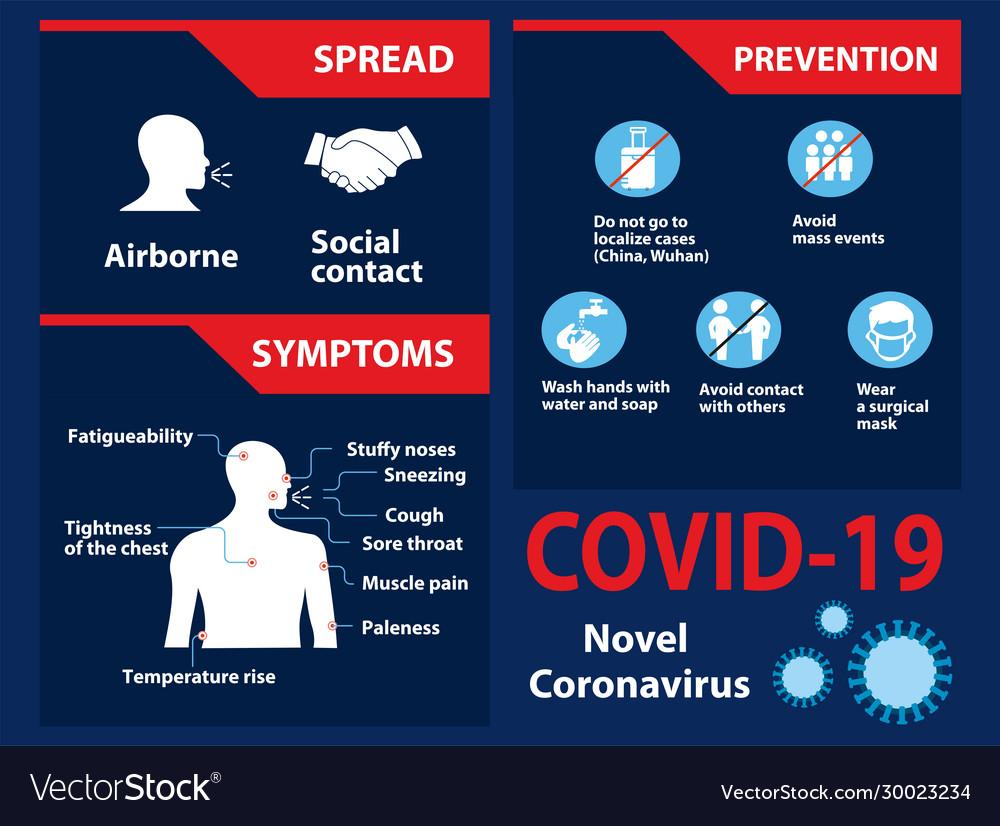Outline some significant characteristics in this image. The coronavirus disease is primarily spread through airborne transmission and social contact, with infected individuals being able to spread the disease to others through coughing, sneezing, and touching contaminated surfaces. It is important to take precautions to prevent the spread of the virus, including frequent hand washing, wearing a mask, and avoiding close contact with those who are infected. The prevention measures of COVID-19 do not mention the number 3, but rather emphasize the importance of practicing good hygiene and avoiding close contact with others. 